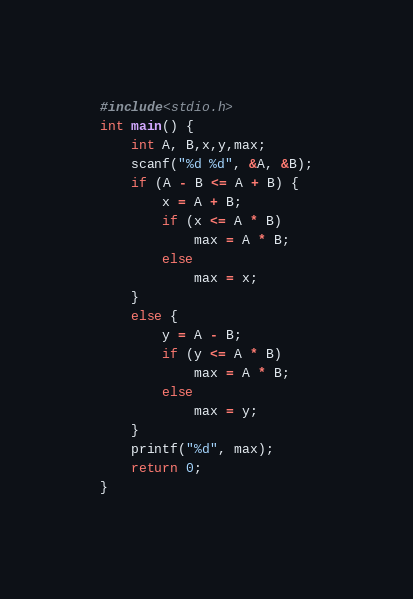<code> <loc_0><loc_0><loc_500><loc_500><_C_>#include<stdio.h>
int main() {
	int A, B,x,y,max;
	scanf("%d %d", &A, &B);
	if (A - B <= A + B) {
		x = A + B;
		if (x <= A * B)
			max = A * B;
		else
			max = x;
	}
	else {
		y = A - B;
		if (y <= A * B)
			max = A * B;
		else
			max = y;
	}
	printf("%d", max);
	return 0;
}</code> 